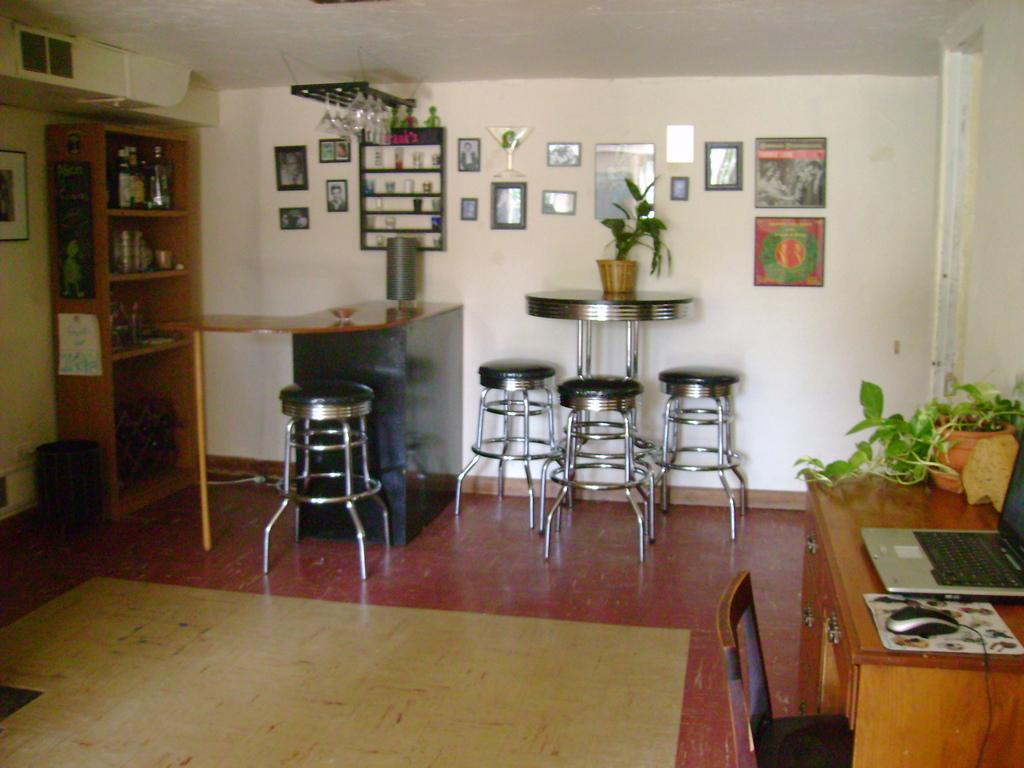What type of furniture is present in the image? There are stools, tables, and a chair in the image. What type of decorative items can be seen in the image? There are house plants and frames on the wall in the image. What type of technology is visible in the image? There is a laptop and a mouse (likely a computer mouse) in the image. What part of the room can be seen in the image? The floor is visible in the image. What type of storage is present in the image? There are objects in racks in the image. What type of door is visible in the image? There is no door visible in the image. What emotion is the laptop feeling in the image? The laptop is an inanimate object and does not have emotions. 